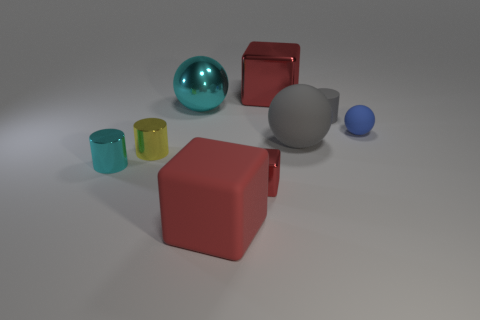What is the tiny red cube made of?
Give a very brief answer. Metal. What is the color of the other matte ball that is the same size as the cyan sphere?
Your answer should be very brief. Gray. Are there any blue rubber things that are to the right of the red block that is behind the gray cylinder?
Your response must be concise. Yes. How many cubes are either large red objects or blue matte things?
Make the answer very short. 2. How big is the cyan shiny thing that is in front of the rubber cylinder that is right of the large red object in front of the large red metal thing?
Your answer should be compact. Small. There is a tiny red block; are there any cubes in front of it?
Your response must be concise. Yes. There is a large object that is the same color as the large metal block; what is its shape?
Offer a very short reply. Cube. What number of objects are big red blocks that are behind the tiny red shiny thing or large brown balls?
Give a very brief answer. 1. What size is the yellow thing that is made of the same material as the tiny block?
Ensure brevity in your answer.  Small. Is the size of the yellow metal cylinder the same as the red object behind the tiny shiny cube?
Provide a succinct answer. No. 